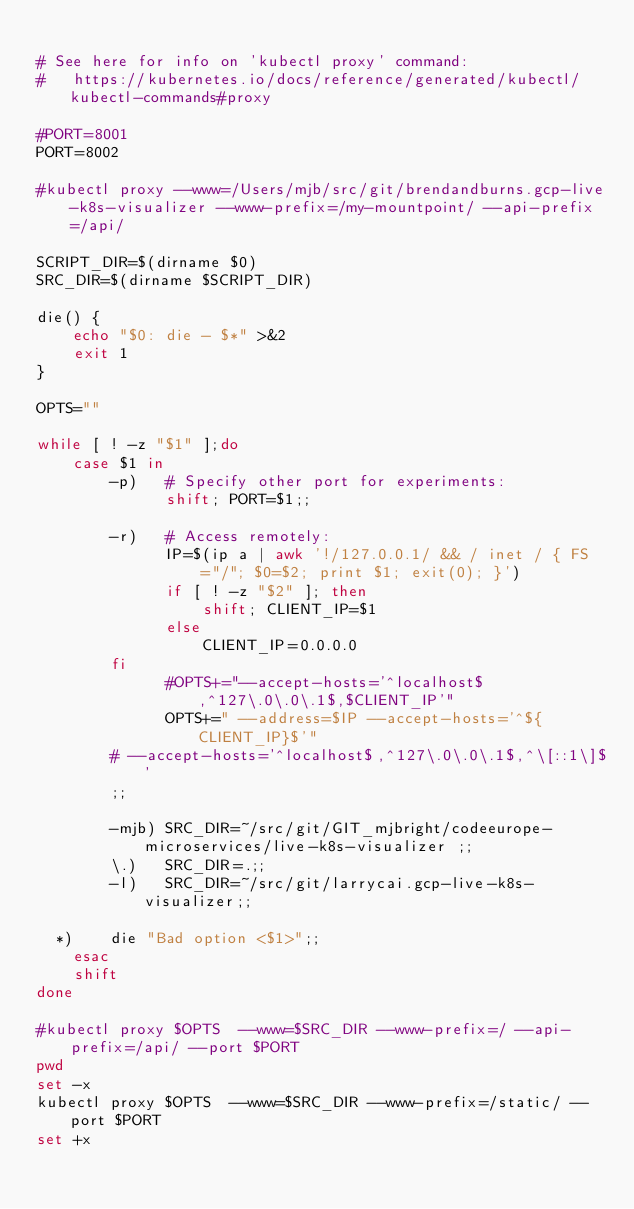<code> <loc_0><loc_0><loc_500><loc_500><_Bash_>
# See here for info on 'kubectl proxy' command:
#   https://kubernetes.io/docs/reference/generated/kubectl/kubectl-commands#proxy

#PORT=8001
PORT=8002

#kubectl proxy --www=/Users/mjb/src/git/brendandburns.gcp-live-k8s-visualizer --www-prefix=/my-mountpoint/ --api-prefix=/api/

SCRIPT_DIR=$(dirname $0)
SRC_DIR=$(dirname $SCRIPT_DIR)

die() {
    echo "$0: die - $*" >&2
    exit 1
}

OPTS=""

while [ ! -z "$1" ];do
    case $1 in
        -p)   # Specify other port for experiments:
              shift; PORT=$1;;

        -r)   # Access remotely:
              IP=$(ip a | awk '!/127.0.0.1/ && / inet / { FS="/"; $0=$2; print $1; exit(0); }')
              if [ ! -z "$2" ]; then
                  shift; CLIENT_IP=$1
              else
                  CLIENT_IP=0.0.0.0
	      fi
              #OPTS+="--accept-hosts='^localhost$,^127\.0\.0\.1$,$CLIENT_IP'"
              OPTS+=" --address=$IP --accept-hosts='^${CLIENT_IP}$'"
	      # --accept-hosts='^localhost$,^127\.0\.0\.1$,^\[::1\]$'
	      ;;

        -mjb) SRC_DIR=~/src/git/GIT_mjbright/codeeurope-microservices/live-k8s-visualizer ;;
        \.)   SRC_DIR=.;;
        -l)   SRC_DIR=~/src/git/larrycai.gcp-live-k8s-visualizer;;

	*)    die "Bad option <$1>";;
    esac
    shift
done

#kubectl proxy $OPTS  --www=$SRC_DIR --www-prefix=/ --api-prefix=/api/ --port $PORT
pwd
set -x
kubectl proxy $OPTS  --www=$SRC_DIR --www-prefix=/static/ --port $PORT
set +x

</code> 